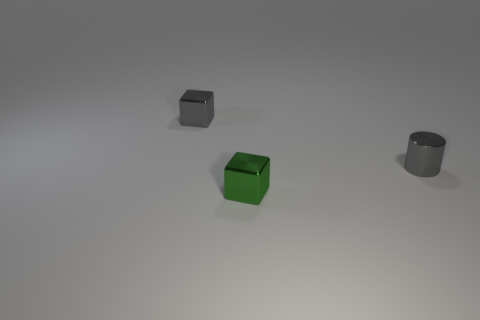Add 3 tiny cubes. How many objects exist? 6 Subtract all blocks. How many objects are left? 1 Add 1 metallic cubes. How many metallic cubes exist? 3 Subtract 1 green cubes. How many objects are left? 2 Subtract all small gray cubes. Subtract all green metallic blocks. How many objects are left? 1 Add 1 tiny metal things. How many tiny metal things are left? 4 